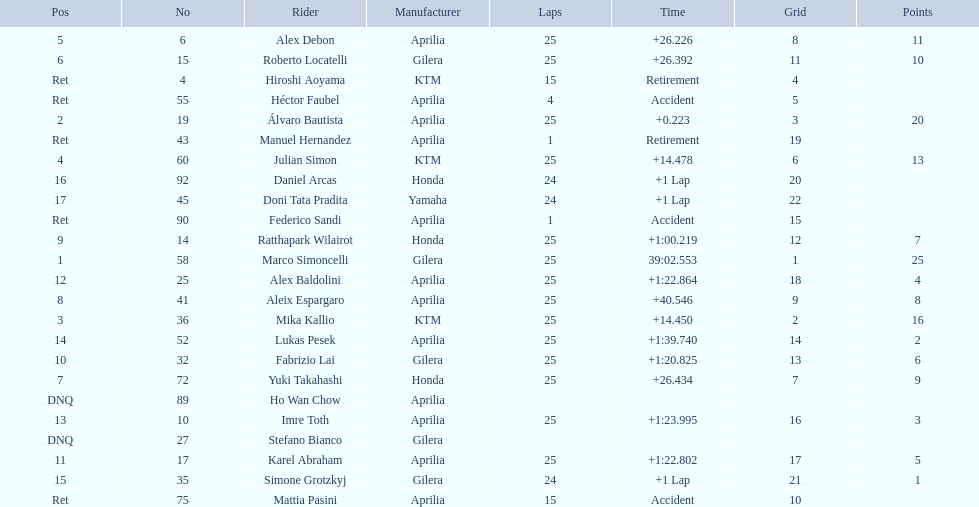What was the fastest overall time? 39:02.553. Who does this time belong to? Marco Simoncelli. 